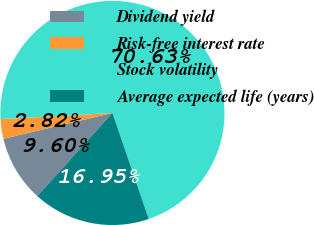Convert chart to OTSL. <chart><loc_0><loc_0><loc_500><loc_500><pie_chart><fcel>Dividend yield<fcel>Risk-free interest rate<fcel>Stock volatility<fcel>Average expected life (years)<nl><fcel>9.6%<fcel>2.82%<fcel>70.62%<fcel>16.95%<nl></chart> 